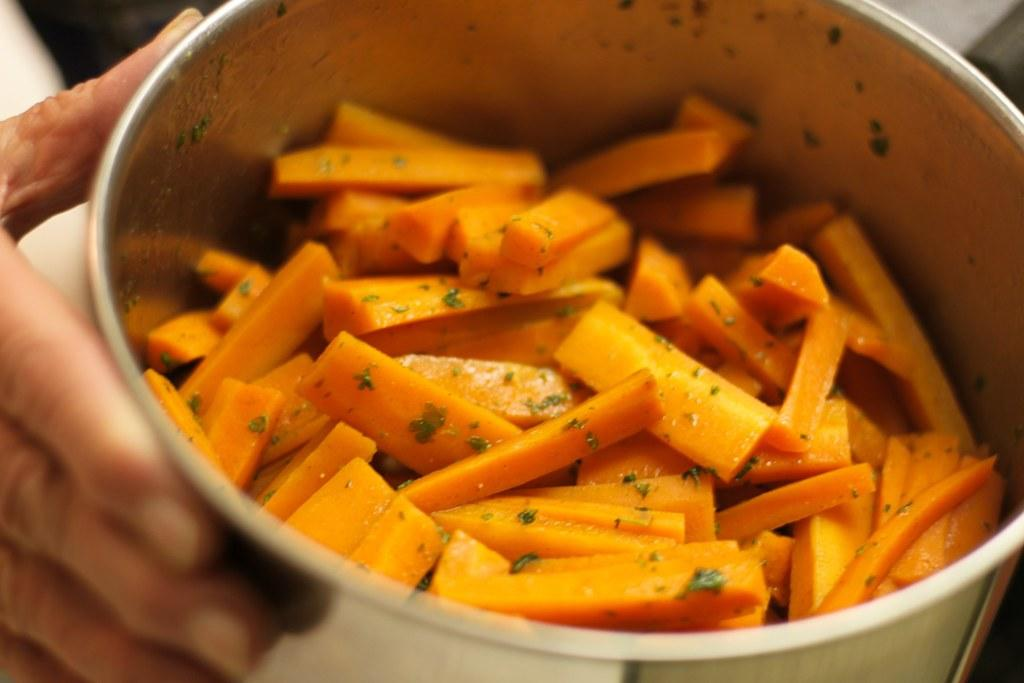What is the main food item in the image? There is a food item in a bowl in the image. Can you describe any other elements in the image? A person's hand is visible in the image. How many birds are flying over the car in the image? There are no birds or cars present in the image. What type of division is being performed in the image? There is no division or mathematical operation being performed in the image. 